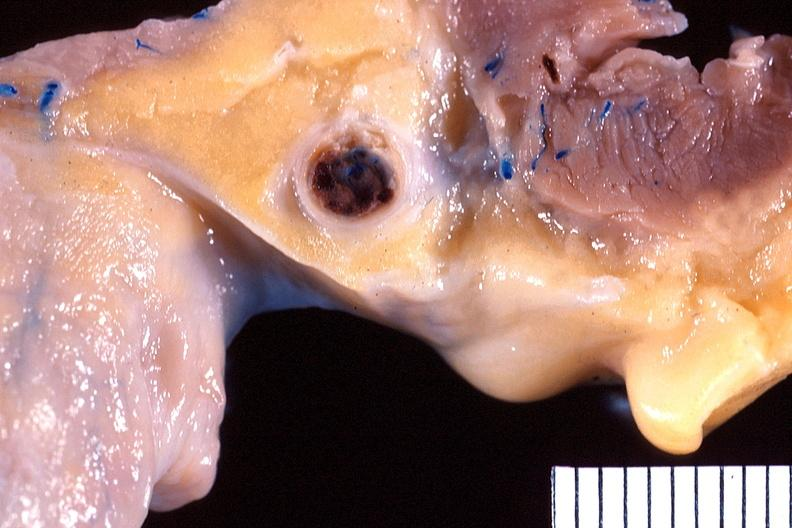does cranial artery show heart, right coronary artery, atherosclerosis and acute thrombus?
Answer the question using a single word or phrase. No 